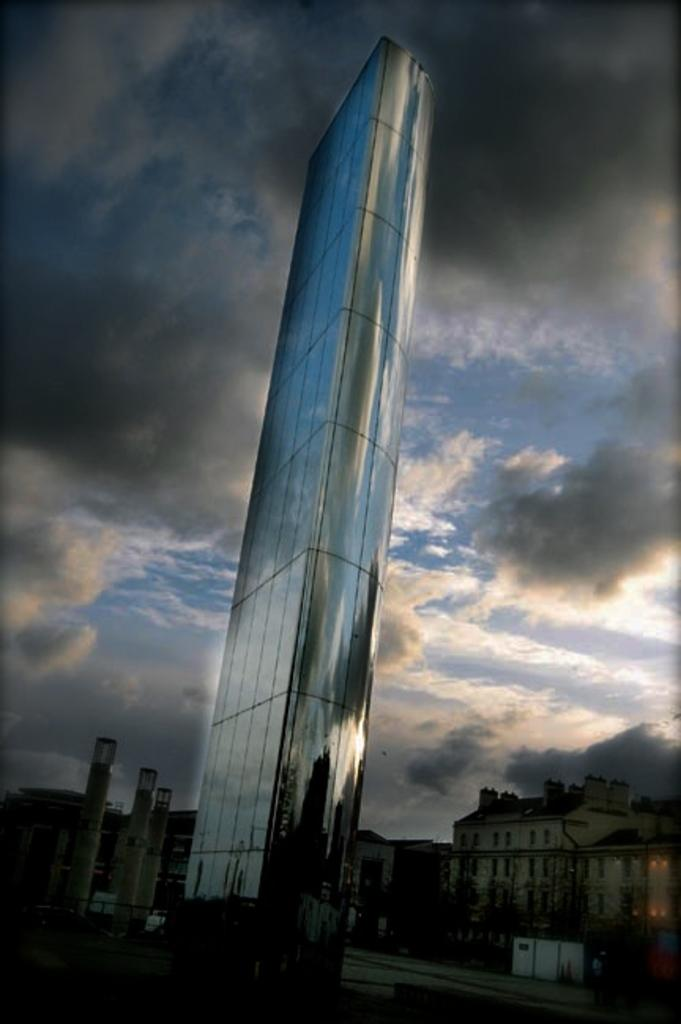What type of natural elements can be seen in the image? There are trees in the image. What type of man-made structures are present in the image? There are buildings in the image. What type of transportation infrastructure is visible in the image? There are roads in the image. What is visible in the sky at the top of the image? There are clouds in the sky at the top of the image. What type of loaf is being used to cover the trees in the image? There is no loaf present in the image, and the trees are not covered. What type of cloth is draped over the buildings in the image? There is no cloth draped over the buildings in the image. 